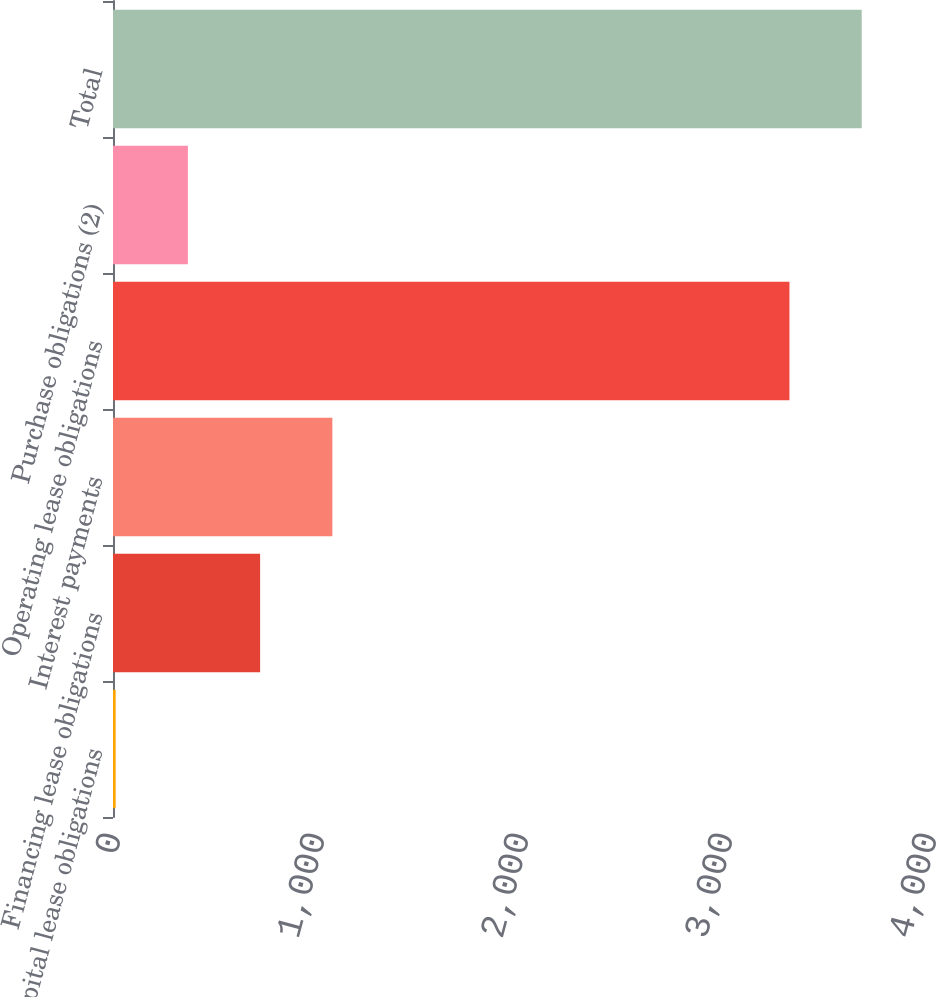<chart> <loc_0><loc_0><loc_500><loc_500><bar_chart><fcel>Capital lease obligations<fcel>Financing lease obligations<fcel>Interest payments<fcel>Operating lease obligations<fcel>Purchase obligations (2)<fcel>Total<nl><fcel>13<fcel>721.2<fcel>1075.3<fcel>3316<fcel>367.1<fcel>3670.1<nl></chart> 